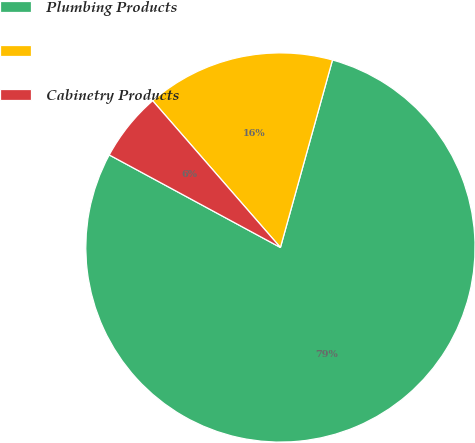Convert chart to OTSL. <chart><loc_0><loc_0><loc_500><loc_500><pie_chart><fcel>Plumbing Products<fcel>Unnamed: 1<fcel>Cabinetry Products<nl><fcel>78.57%<fcel>15.71%<fcel>5.71%<nl></chart> 